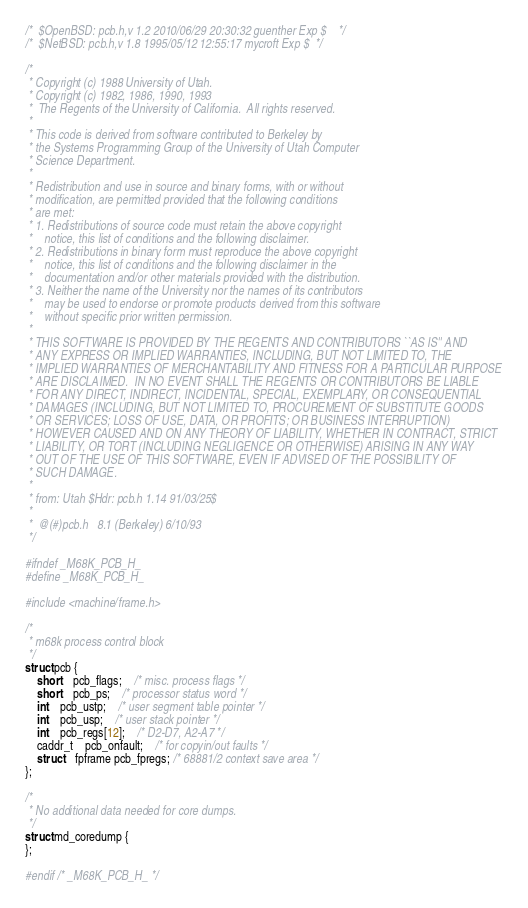<code> <loc_0><loc_0><loc_500><loc_500><_C_>/*	$OpenBSD: pcb.h,v 1.2 2010/06/29 20:30:32 guenther Exp $	*/
/*	$NetBSD: pcb.h,v 1.8 1995/05/12 12:55:17 mycroft Exp $	*/

/*
 * Copyright (c) 1988 University of Utah.
 * Copyright (c) 1982, 1986, 1990, 1993
 *	The Regents of the University of California.  All rights reserved.
 *
 * This code is derived from software contributed to Berkeley by
 * the Systems Programming Group of the University of Utah Computer
 * Science Department.
 *
 * Redistribution and use in source and binary forms, with or without
 * modification, are permitted provided that the following conditions
 * are met:
 * 1. Redistributions of source code must retain the above copyright
 *    notice, this list of conditions and the following disclaimer.
 * 2. Redistributions in binary form must reproduce the above copyright
 *    notice, this list of conditions and the following disclaimer in the
 *    documentation and/or other materials provided with the distribution.
 * 3. Neither the name of the University nor the names of its contributors
 *    may be used to endorse or promote products derived from this software
 *    without specific prior written permission.
 *
 * THIS SOFTWARE IS PROVIDED BY THE REGENTS AND CONTRIBUTORS ``AS IS'' AND
 * ANY EXPRESS OR IMPLIED WARRANTIES, INCLUDING, BUT NOT LIMITED TO, THE
 * IMPLIED WARRANTIES OF MERCHANTABILITY AND FITNESS FOR A PARTICULAR PURPOSE
 * ARE DISCLAIMED.  IN NO EVENT SHALL THE REGENTS OR CONTRIBUTORS BE LIABLE
 * FOR ANY DIRECT, INDIRECT, INCIDENTAL, SPECIAL, EXEMPLARY, OR CONSEQUENTIAL
 * DAMAGES (INCLUDING, BUT NOT LIMITED TO, PROCUREMENT OF SUBSTITUTE GOODS
 * OR SERVICES; LOSS OF USE, DATA, OR PROFITS; OR BUSINESS INTERRUPTION)
 * HOWEVER CAUSED AND ON ANY THEORY OF LIABILITY, WHETHER IN CONTRACT, STRICT
 * LIABILITY, OR TORT (INCLUDING NEGLIGENCE OR OTHERWISE) ARISING IN ANY WAY
 * OUT OF THE USE OF THIS SOFTWARE, EVEN IF ADVISED OF THE POSSIBILITY OF
 * SUCH DAMAGE.
 *
 * from: Utah $Hdr: pcb.h 1.14 91/03/25$
 *
 *	@(#)pcb.h	8.1 (Berkeley) 6/10/93
 */

#ifndef _M68K_PCB_H_
#define _M68K_PCB_H_

#include <machine/frame.h>

/*
 * m68k process control block
 */
struct pcb {
	short	pcb_flags;	/* misc. process flags */
	short	pcb_ps; 	/* processor status word */
	int	pcb_ustp;	/* user segment table pointer */
	int	pcb_usp;	/* user stack pointer */
	int	pcb_regs[12];	/* D2-D7, A2-A7 */
	caddr_t	pcb_onfault;	/* for copyin/out faults */
	struct	fpframe pcb_fpregs; /* 68881/2 context save area */
};

/*
 * No additional data needed for core dumps.
 */
struct md_coredump {
};

#endif /* _M68K_PCB_H_ */
</code> 